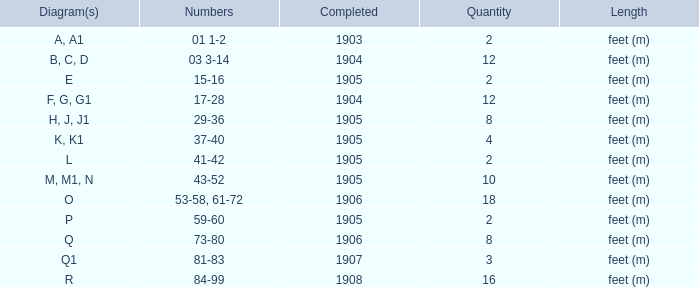What is the quantity of the item with the numbers of 29-36? 8.0. 